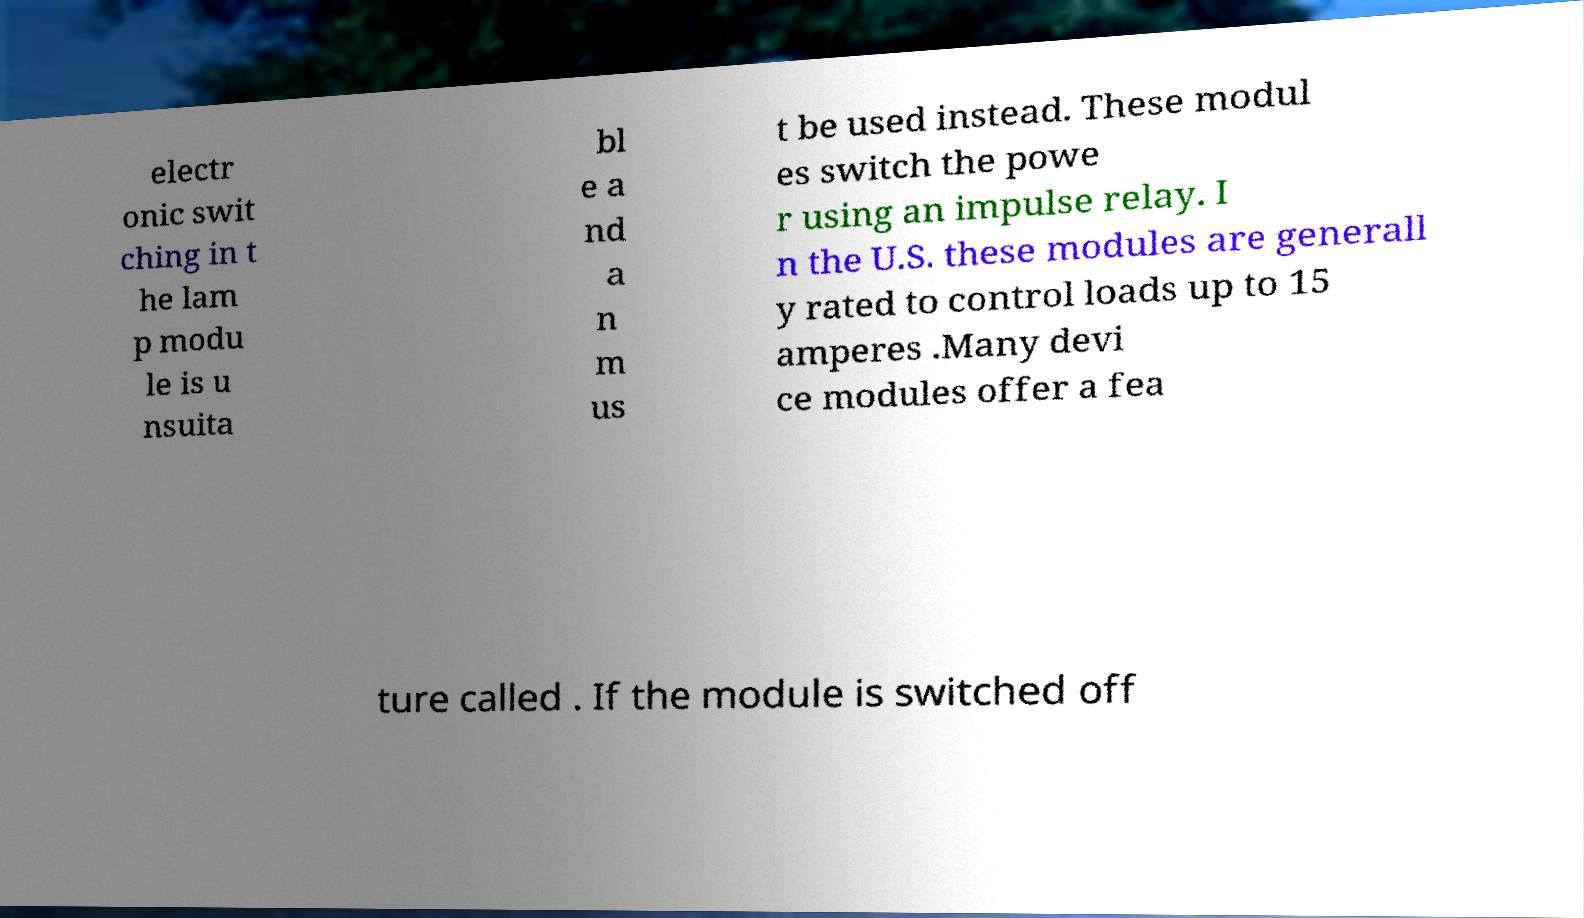What messages or text are displayed in this image? I need them in a readable, typed format. electr onic swit ching in t he lam p modu le is u nsuita bl e a nd a n m us t be used instead. These modul es switch the powe r using an impulse relay. I n the U.S. these modules are generall y rated to control loads up to 15 amperes .Many devi ce modules offer a fea ture called . If the module is switched off 